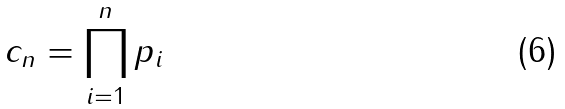Convert formula to latex. <formula><loc_0><loc_0><loc_500><loc_500>c _ { n } = \prod _ { i = 1 } ^ { n } p _ { i }</formula> 